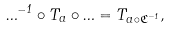Convert formula to latex. <formula><loc_0><loc_0><loc_500><loc_500>\Phi ^ { - 1 } \circ T _ { a } \circ \Phi = T _ { a \circ \mathfrak { C } ^ { - 1 } } ,</formula> 